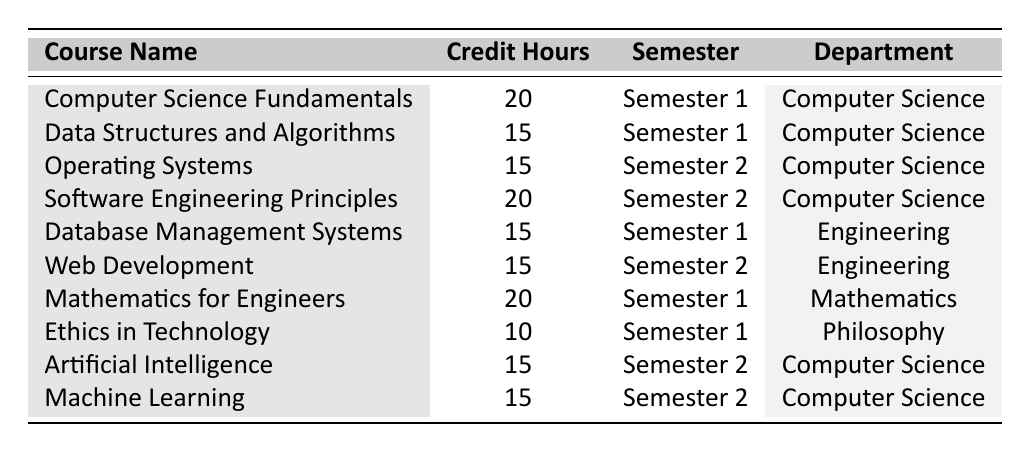What is the credit hour value for "Mathematics for Engineers"? In the table, find the row where the course name matches "Mathematics for Engineers." The corresponding credit hour value listed next to this course is 20.
Answer: 20 Which semester is "Web Development" offered? Look at the row for "Web Development" in the table. Next to the course name, the semester is listed as "Semester 2."
Answer: Semester 2 How many courses are offered in Semester 1? Count the number of rows where the semester is listed as "Semester 1." There are 5 courses in that semester.
Answer: 5 What is the total credit hours for all Computer Science courses? Identify the rows for all Computer Science courses and sum their credit hour values: 20 (Computer Science Fundamentals) + 15 (Data Structures and Algorithms) + 15 (Operating Systems) + 20 (Software Engineering Principles) + 15 (Artificial Intelligence) + 15 (Machine Learning) = 100.
Answer: 100 Is there a course with less than 10 credit hours? Check each credit hour value in the table to see if any are less than 10. The smallest value listed is 10 for "Ethics in Technology," so there is no course with less than 10 credit hours.
Answer: No What is the average credit hour value of courses in Semester 2? Identify the credit hours for Semester 2 courses: 15 (Operating Systems), 20 (Software Engineering Principles), 15 (Web Development), 15 (Artificial Intelligence), and 15 (Machine Learning). This gives a total of 80 hours across 5 courses: 80/5 = 16.
Answer: 16 Which department has the course with the highest credit hours and what is that course? Review the credit hours in the table: "Mathematics for Engineers," "Computer Science Fundamentals," and "Software Engineering Principles" each have 20 hours, which is the highest value. The departments are Mathematics and Computer Science.
Answer: Mathematics and Computer Science for courses with 20 hours How many courses are there in the Engineering department? Count the rows where the 'Department' column is "Engineering." There are 2 courses: "Database Management Systems" and "Web Development."
Answer: 2 What is the difference in credit hours between the course with the highest and lowest values? Identify the highest credit hours (20 for "Computer Science Fundamentals" and "Mathematics for Engineers") and the lowest (10 for "Ethics in Technology"). The difference is 20 - 10 = 10.
Answer: 10 Are there any courses offered by the Philosophy department? Look at the 'Department' column for any instances of "Philosophy." The course "Ethics in Technology" is listed under this department.
Answer: Yes 